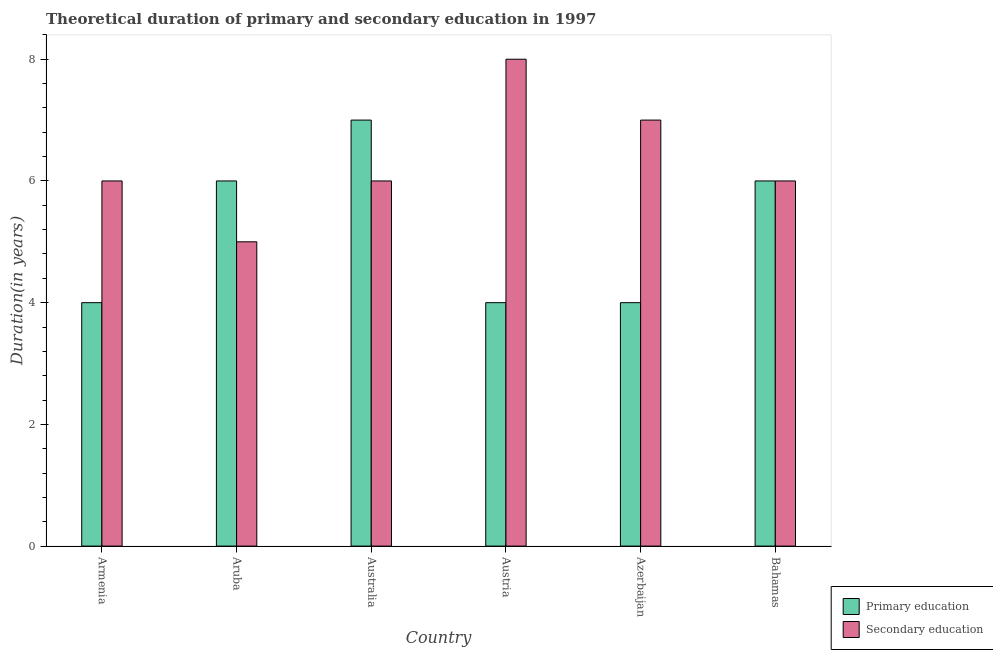How many groups of bars are there?
Make the answer very short. 6. Are the number of bars on each tick of the X-axis equal?
Your answer should be very brief. Yes. How many bars are there on the 5th tick from the left?
Offer a very short reply. 2. How many bars are there on the 4th tick from the right?
Offer a very short reply. 2. What is the label of the 1st group of bars from the left?
Your response must be concise. Armenia. What is the duration of primary education in Australia?
Your answer should be compact. 7. Across all countries, what is the maximum duration of secondary education?
Your answer should be compact. 8. Across all countries, what is the minimum duration of primary education?
Provide a succinct answer. 4. In which country was the duration of secondary education minimum?
Ensure brevity in your answer.  Aruba. What is the total duration of secondary education in the graph?
Offer a terse response. 38. What is the difference between the duration of primary education in Armenia and that in Australia?
Your response must be concise. -3. What is the difference between the duration of primary education in Aruba and the duration of secondary education in Austria?
Offer a terse response. -2. What is the average duration of primary education per country?
Provide a short and direct response. 5.17. What is the ratio of the duration of secondary education in Armenia to that in Bahamas?
Give a very brief answer. 1. What is the difference between the highest and the second highest duration of secondary education?
Provide a short and direct response. 1. What is the difference between the highest and the lowest duration of primary education?
Ensure brevity in your answer.  3. In how many countries, is the duration of primary education greater than the average duration of primary education taken over all countries?
Offer a very short reply. 3. What does the 1st bar from the left in Armenia represents?
Provide a succinct answer. Primary education. What does the 1st bar from the right in Austria represents?
Provide a succinct answer. Secondary education. How many bars are there?
Your answer should be compact. 12. What is the difference between two consecutive major ticks on the Y-axis?
Offer a terse response. 2. Are the values on the major ticks of Y-axis written in scientific E-notation?
Your answer should be very brief. No. Does the graph contain any zero values?
Keep it short and to the point. No. Does the graph contain grids?
Ensure brevity in your answer.  No. How are the legend labels stacked?
Offer a terse response. Vertical. What is the title of the graph?
Offer a very short reply. Theoretical duration of primary and secondary education in 1997. What is the label or title of the Y-axis?
Keep it short and to the point. Duration(in years). What is the Duration(in years) in Primary education in Aruba?
Keep it short and to the point. 6. What is the Duration(in years) of Secondary education in Australia?
Ensure brevity in your answer.  6. What is the Duration(in years) of Primary education in Austria?
Ensure brevity in your answer.  4. What is the Duration(in years) in Primary education in Bahamas?
Give a very brief answer. 6. Across all countries, what is the maximum Duration(in years) in Primary education?
Give a very brief answer. 7. Across all countries, what is the minimum Duration(in years) in Secondary education?
Your answer should be compact. 5. What is the difference between the Duration(in years) of Primary education in Armenia and that in Aruba?
Keep it short and to the point. -2. What is the difference between the Duration(in years) in Secondary education in Armenia and that in Aruba?
Make the answer very short. 1. What is the difference between the Duration(in years) in Primary education in Armenia and that in Australia?
Provide a short and direct response. -3. What is the difference between the Duration(in years) of Primary education in Armenia and that in Azerbaijan?
Offer a very short reply. 0. What is the difference between the Duration(in years) of Secondary education in Armenia and that in Azerbaijan?
Give a very brief answer. -1. What is the difference between the Duration(in years) in Primary education in Armenia and that in Bahamas?
Your response must be concise. -2. What is the difference between the Duration(in years) of Primary education in Aruba and that in Australia?
Make the answer very short. -1. What is the difference between the Duration(in years) of Secondary education in Aruba and that in Australia?
Offer a very short reply. -1. What is the difference between the Duration(in years) of Primary education in Aruba and that in Austria?
Make the answer very short. 2. What is the difference between the Duration(in years) of Primary education in Aruba and that in Azerbaijan?
Ensure brevity in your answer.  2. What is the difference between the Duration(in years) in Primary education in Aruba and that in Bahamas?
Provide a short and direct response. 0. What is the difference between the Duration(in years) in Primary education in Australia and that in Austria?
Your answer should be compact. 3. What is the difference between the Duration(in years) of Secondary education in Australia and that in Austria?
Provide a succinct answer. -2. What is the difference between the Duration(in years) in Primary education in Australia and that in Azerbaijan?
Your response must be concise. 3. What is the difference between the Duration(in years) in Primary education in Australia and that in Bahamas?
Ensure brevity in your answer.  1. What is the difference between the Duration(in years) in Secondary education in Australia and that in Bahamas?
Offer a terse response. 0. What is the difference between the Duration(in years) of Primary education in Austria and that in Azerbaijan?
Provide a succinct answer. 0. What is the difference between the Duration(in years) in Secondary education in Austria and that in Azerbaijan?
Provide a succinct answer. 1. What is the difference between the Duration(in years) of Secondary education in Austria and that in Bahamas?
Your answer should be very brief. 2. What is the difference between the Duration(in years) in Secondary education in Azerbaijan and that in Bahamas?
Provide a short and direct response. 1. What is the difference between the Duration(in years) of Primary education in Armenia and the Duration(in years) of Secondary education in Aruba?
Keep it short and to the point. -1. What is the difference between the Duration(in years) of Primary education in Armenia and the Duration(in years) of Secondary education in Azerbaijan?
Provide a short and direct response. -3. What is the difference between the Duration(in years) of Primary education in Aruba and the Duration(in years) of Secondary education in Australia?
Give a very brief answer. 0. What is the difference between the Duration(in years) in Primary education in Aruba and the Duration(in years) in Secondary education in Austria?
Offer a very short reply. -2. What is the difference between the Duration(in years) of Primary education in Aruba and the Duration(in years) of Secondary education in Bahamas?
Give a very brief answer. 0. What is the difference between the Duration(in years) of Primary education in Australia and the Duration(in years) of Secondary education in Austria?
Make the answer very short. -1. What is the difference between the Duration(in years) of Primary education in Australia and the Duration(in years) of Secondary education in Azerbaijan?
Ensure brevity in your answer.  0. What is the difference between the Duration(in years) in Primary education in Austria and the Duration(in years) in Secondary education in Azerbaijan?
Your answer should be compact. -3. What is the difference between the Duration(in years) in Primary education in Azerbaijan and the Duration(in years) in Secondary education in Bahamas?
Keep it short and to the point. -2. What is the average Duration(in years) in Primary education per country?
Provide a short and direct response. 5.17. What is the average Duration(in years) in Secondary education per country?
Your answer should be very brief. 6.33. What is the difference between the Duration(in years) of Primary education and Duration(in years) of Secondary education in Armenia?
Your response must be concise. -2. What is the difference between the Duration(in years) of Primary education and Duration(in years) of Secondary education in Azerbaijan?
Offer a terse response. -3. What is the ratio of the Duration(in years) in Primary education in Armenia to that in Aruba?
Your answer should be compact. 0.67. What is the ratio of the Duration(in years) of Secondary education in Armenia to that in Aruba?
Provide a succinct answer. 1.2. What is the ratio of the Duration(in years) of Primary education in Armenia to that in Australia?
Your answer should be compact. 0.57. What is the ratio of the Duration(in years) of Secondary education in Armenia to that in Australia?
Provide a short and direct response. 1. What is the ratio of the Duration(in years) in Secondary education in Armenia to that in Austria?
Your answer should be compact. 0.75. What is the ratio of the Duration(in years) of Primary education in Armenia to that in Bahamas?
Your answer should be compact. 0.67. What is the ratio of the Duration(in years) of Secondary education in Armenia to that in Bahamas?
Give a very brief answer. 1. What is the ratio of the Duration(in years) in Secondary education in Aruba to that in Australia?
Your answer should be very brief. 0.83. What is the ratio of the Duration(in years) of Primary education in Aruba to that in Bahamas?
Ensure brevity in your answer.  1. What is the ratio of the Duration(in years) in Secondary education in Aruba to that in Bahamas?
Your response must be concise. 0.83. What is the ratio of the Duration(in years) of Primary education in Australia to that in Austria?
Provide a succinct answer. 1.75. What is the ratio of the Duration(in years) of Secondary education in Australia to that in Austria?
Make the answer very short. 0.75. What is the ratio of the Duration(in years) of Primary education in Australia to that in Azerbaijan?
Provide a succinct answer. 1.75. What is the ratio of the Duration(in years) of Secondary education in Austria to that in Azerbaijan?
Ensure brevity in your answer.  1.14. What is the ratio of the Duration(in years) in Primary education in Austria to that in Bahamas?
Your answer should be compact. 0.67. What is the ratio of the Duration(in years) in Secondary education in Azerbaijan to that in Bahamas?
Your answer should be compact. 1.17. What is the difference between the highest and the second highest Duration(in years) of Primary education?
Offer a very short reply. 1. What is the difference between the highest and the second highest Duration(in years) of Secondary education?
Provide a succinct answer. 1. 